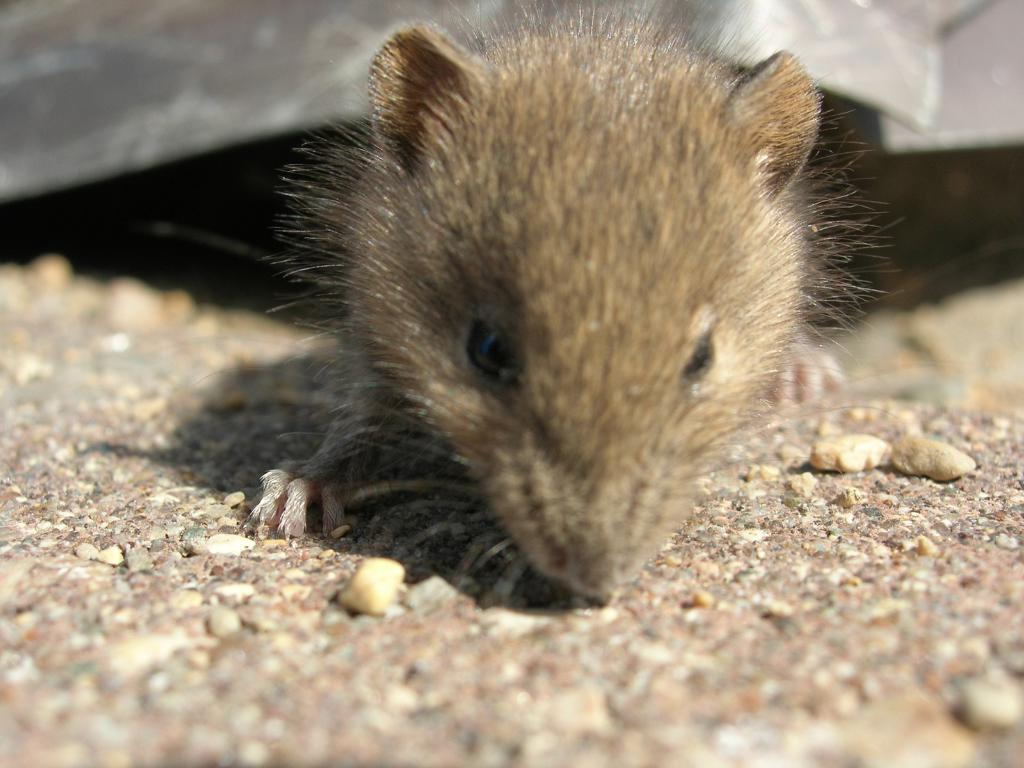What type of animal is in the image? There is a small, cute rat in the image. What type of produce is the rat holding in the image? There is no produce present in the image; it features a small, cute rat. What type of pipe is visible in the image? There is no pipe present in the image; it features a small, cute rat. 